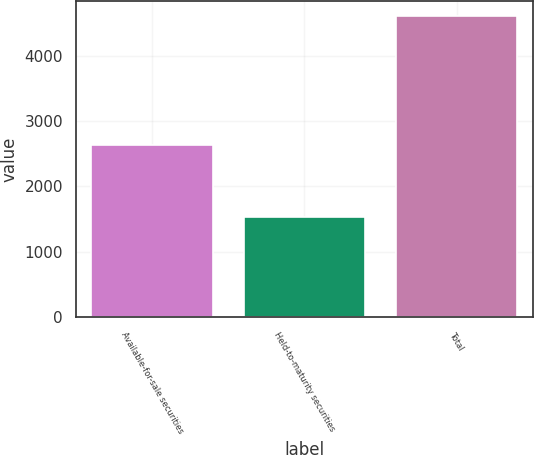Convert chart. <chart><loc_0><loc_0><loc_500><loc_500><bar_chart><fcel>Available-for-sale securities<fcel>Held-to-maturity securities<fcel>Total<nl><fcel>2625<fcel>1533<fcel>4607<nl></chart> 